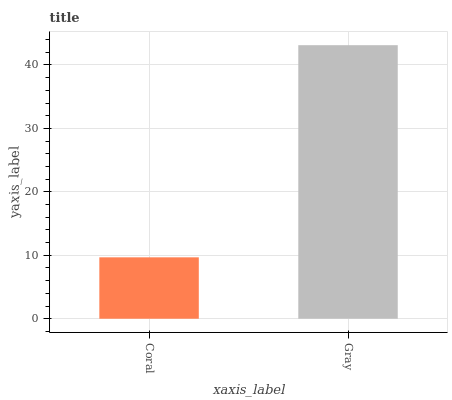Is Coral the minimum?
Answer yes or no. Yes. Is Gray the maximum?
Answer yes or no. Yes. Is Gray the minimum?
Answer yes or no. No. Is Gray greater than Coral?
Answer yes or no. Yes. Is Coral less than Gray?
Answer yes or no. Yes. Is Coral greater than Gray?
Answer yes or no. No. Is Gray less than Coral?
Answer yes or no. No. Is Gray the high median?
Answer yes or no. Yes. Is Coral the low median?
Answer yes or no. Yes. Is Coral the high median?
Answer yes or no. No. Is Gray the low median?
Answer yes or no. No. 